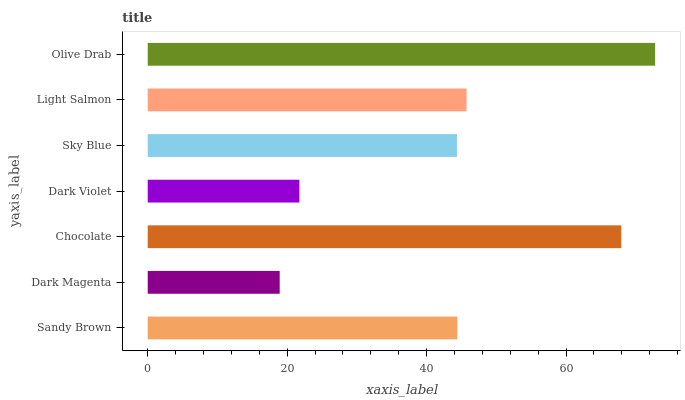Is Dark Magenta the minimum?
Answer yes or no. Yes. Is Olive Drab the maximum?
Answer yes or no. Yes. Is Chocolate the minimum?
Answer yes or no. No. Is Chocolate the maximum?
Answer yes or no. No. Is Chocolate greater than Dark Magenta?
Answer yes or no. Yes. Is Dark Magenta less than Chocolate?
Answer yes or no. Yes. Is Dark Magenta greater than Chocolate?
Answer yes or no. No. Is Chocolate less than Dark Magenta?
Answer yes or no. No. Is Sandy Brown the high median?
Answer yes or no. Yes. Is Sandy Brown the low median?
Answer yes or no. Yes. Is Olive Drab the high median?
Answer yes or no. No. Is Dark Violet the low median?
Answer yes or no. No. 